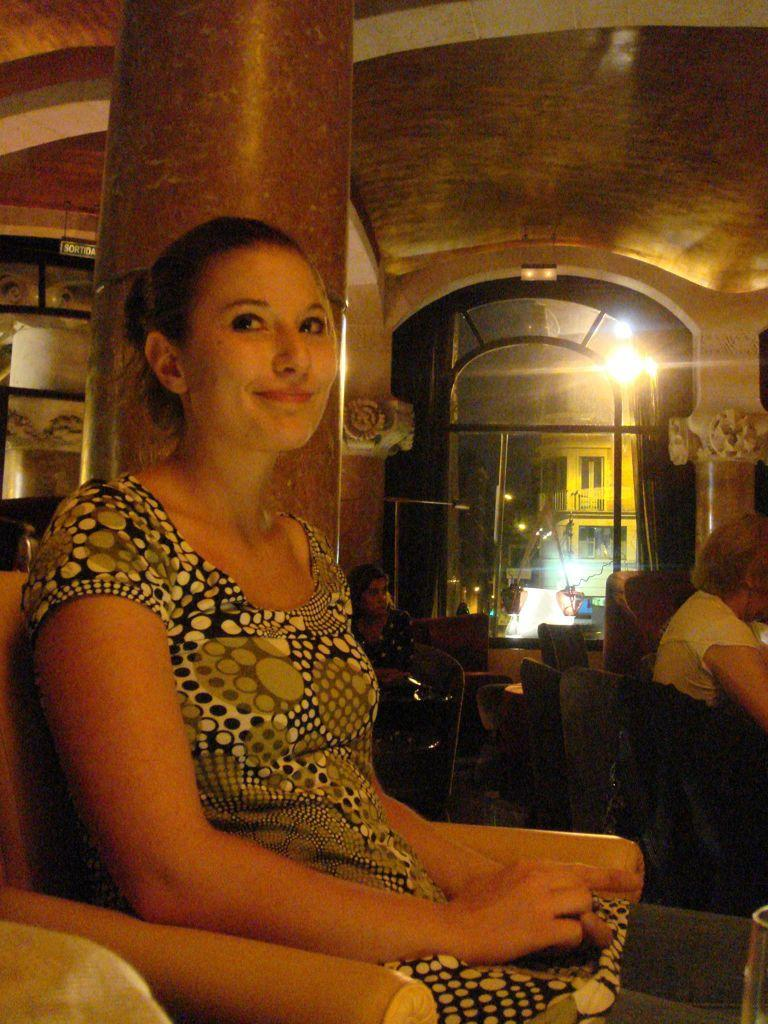Who is the main subject in the image? There is a woman in the image. What is the woman doing in the image? The woman is sitting on a sofa. Are there any other people in the image? Yes, there are two other persons in the background of the image. What are the two other persons doing in the image? The two other persons are also sitting. What type of jewel is the woman wearing on her forehead in the image? There is no jewel visible on the woman's forehead in the image. 